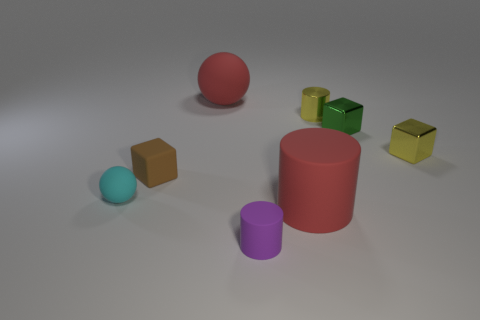Is the color of the big cylinder the same as the large ball?
Make the answer very short. Yes. There is a big rubber object in front of the small cyan matte object; does it have the same color as the matte sphere that is behind the small cyan rubber thing?
Offer a very short reply. Yes. How many objects have the same color as the big matte sphere?
Make the answer very short. 1. There is a brown block; how many matte spheres are to the left of it?
Give a very brief answer. 1. There is a rubber cylinder in front of the large thing that is in front of the small cyan sphere; what is its color?
Offer a very short reply. Purple. Are there any other things that have the same shape as the small purple matte thing?
Provide a short and direct response. Yes. Is the number of small yellow things that are to the left of the yellow cylinder the same as the number of purple matte objects that are to the right of the tiny brown cube?
Your answer should be very brief. No. What number of balls are red matte objects or tiny yellow shiny objects?
Give a very brief answer. 1. What number of other objects are the same material as the yellow cube?
Offer a terse response. 2. There is a object that is on the left side of the matte block; what shape is it?
Your answer should be compact. Sphere. 